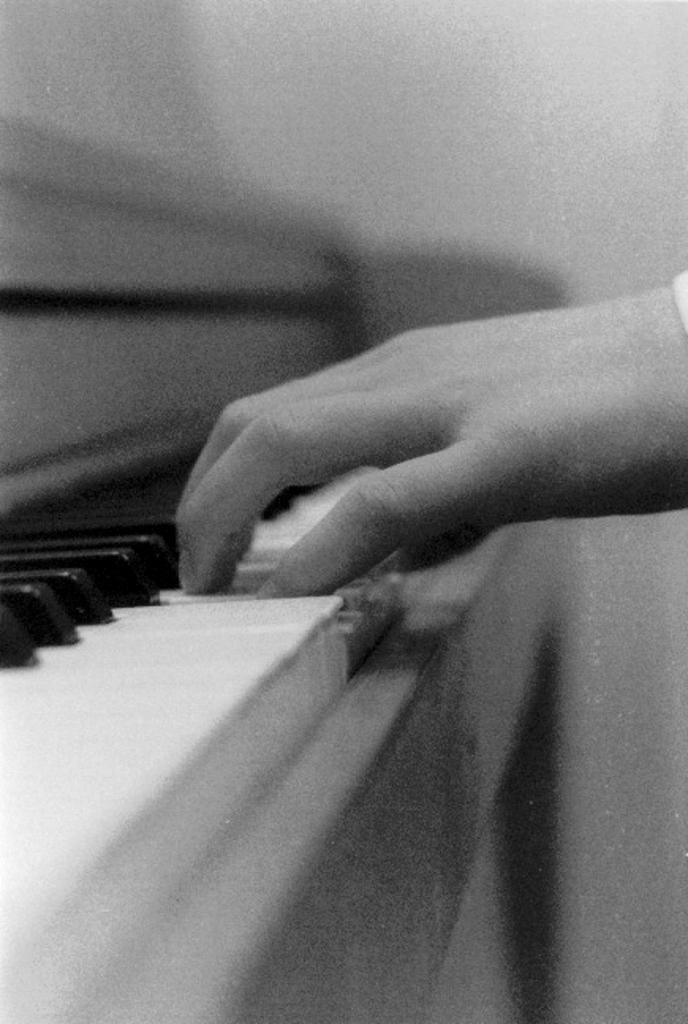What is the color scheme of the image? The image is black and white. Can you describe the main subject in the image? There is a person in the image. What is the person doing in the image? The person's hand is on a piano. How would you describe the background of the image? The background has a blurred view. Is there a current flowing through the piano in the image? There is no indication of a current or electricity in the image; it is a person playing a piano in a black and white setting. 